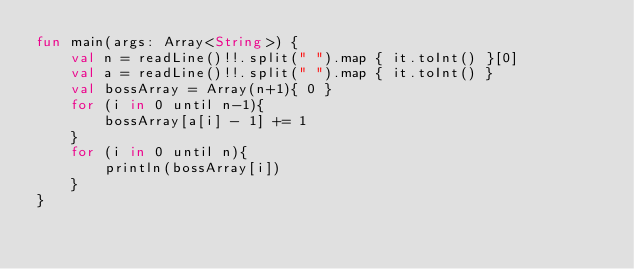Convert code to text. <code><loc_0><loc_0><loc_500><loc_500><_Kotlin_>fun main(args: Array<String>) {
    val n = readLine()!!.split(" ").map { it.toInt() }[0]
    val a = readLine()!!.split(" ").map { it.toInt() }
    val bossArray = Array(n+1){ 0 }
    for (i in 0 until n-1){
        bossArray[a[i] - 1] += 1
    }
    for (i in 0 until n){
        println(bossArray[i])
    }
}
</code> 